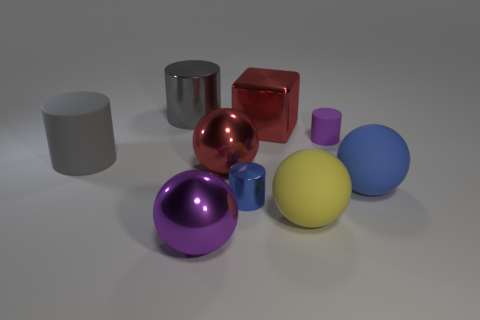How many balls are either small blue objects or purple rubber things?
Ensure brevity in your answer.  0. How many cylinders are behind the red shiny thing that is in front of the rubber cylinder left of the large gray metal object?
Offer a terse response. 3. There is a big blue thing that is the same shape as the yellow matte thing; what material is it?
Provide a short and direct response. Rubber. Is there any other thing that has the same material as the cube?
Provide a succinct answer. Yes. The large metallic ball that is in front of the yellow rubber ball is what color?
Make the answer very short. Purple. Is the material of the purple ball the same as the large cylinder that is behind the red block?
Ensure brevity in your answer.  Yes. What is the large purple thing made of?
Provide a succinct answer. Metal. There is a purple thing that is the same material as the big red ball; what shape is it?
Offer a terse response. Sphere. How many other things are the same shape as the tiny blue thing?
Provide a short and direct response. 3. There is a tiny shiny cylinder; what number of rubber spheres are in front of it?
Provide a short and direct response. 1. 